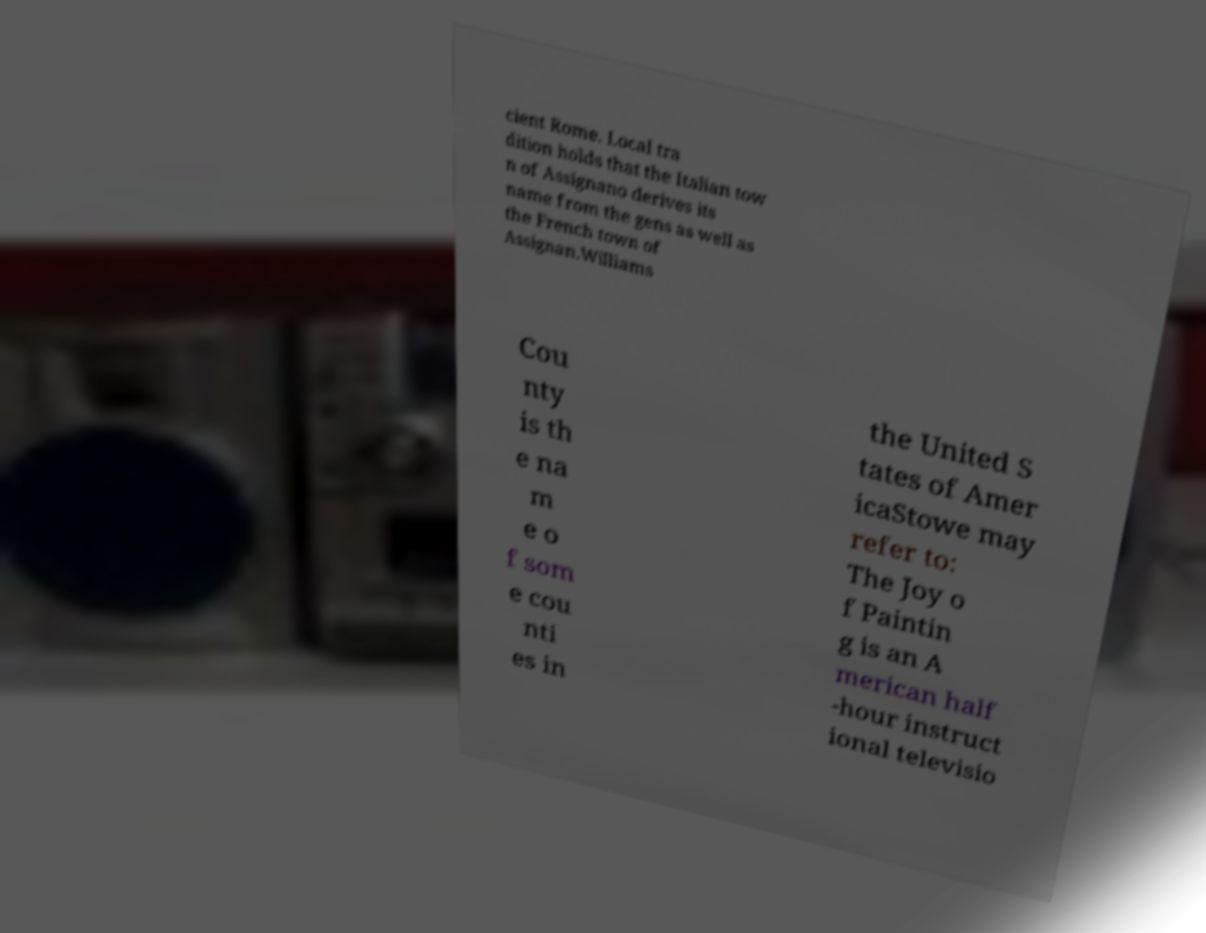Can you read and provide the text displayed in the image?This photo seems to have some interesting text. Can you extract and type it out for me? cient Rome. Local tra dition holds that the Italian tow n of Assignano derives its name from the gens as well as the French town of Assignan.Williams Cou nty is th e na m e o f som e cou nti es in the United S tates of Amer icaStowe may refer to: The Joy o f Paintin g is an A merican half -hour instruct ional televisio 